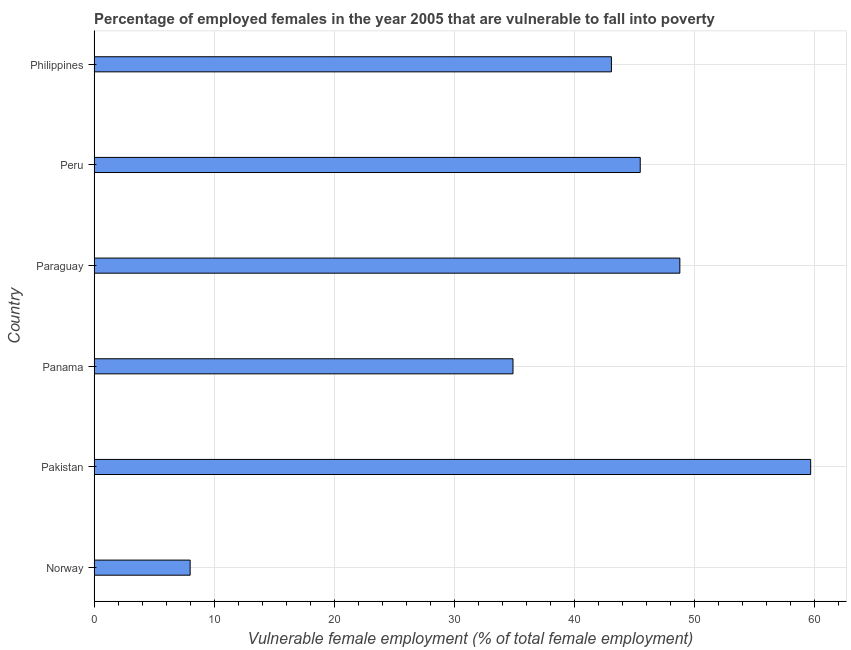Does the graph contain grids?
Provide a short and direct response. Yes. What is the title of the graph?
Offer a terse response. Percentage of employed females in the year 2005 that are vulnerable to fall into poverty. What is the label or title of the X-axis?
Provide a short and direct response. Vulnerable female employment (% of total female employment). What is the percentage of employed females who are vulnerable to fall into poverty in Peru?
Give a very brief answer. 45.5. Across all countries, what is the maximum percentage of employed females who are vulnerable to fall into poverty?
Keep it short and to the point. 59.7. Across all countries, what is the minimum percentage of employed females who are vulnerable to fall into poverty?
Keep it short and to the point. 8. In which country was the percentage of employed females who are vulnerable to fall into poverty maximum?
Offer a terse response. Pakistan. In which country was the percentage of employed females who are vulnerable to fall into poverty minimum?
Offer a terse response. Norway. What is the sum of the percentage of employed females who are vulnerable to fall into poverty?
Your answer should be very brief. 240. What is the difference between the percentage of employed females who are vulnerable to fall into poverty in Peru and Philippines?
Make the answer very short. 2.4. What is the average percentage of employed females who are vulnerable to fall into poverty per country?
Keep it short and to the point. 40. What is the median percentage of employed females who are vulnerable to fall into poverty?
Offer a terse response. 44.3. In how many countries, is the percentage of employed females who are vulnerable to fall into poverty greater than 4 %?
Your response must be concise. 6. What is the ratio of the percentage of employed females who are vulnerable to fall into poverty in Norway to that in Pakistan?
Make the answer very short. 0.13. Is the difference between the percentage of employed females who are vulnerable to fall into poverty in Peru and Philippines greater than the difference between any two countries?
Offer a very short reply. No. What is the difference between the highest and the lowest percentage of employed females who are vulnerable to fall into poverty?
Provide a succinct answer. 51.7. In how many countries, is the percentage of employed females who are vulnerable to fall into poverty greater than the average percentage of employed females who are vulnerable to fall into poverty taken over all countries?
Provide a short and direct response. 4. How many bars are there?
Ensure brevity in your answer.  6. Are all the bars in the graph horizontal?
Your answer should be very brief. Yes. How many countries are there in the graph?
Ensure brevity in your answer.  6. Are the values on the major ticks of X-axis written in scientific E-notation?
Ensure brevity in your answer.  No. What is the Vulnerable female employment (% of total female employment) of Norway?
Your response must be concise. 8. What is the Vulnerable female employment (% of total female employment) of Pakistan?
Keep it short and to the point. 59.7. What is the Vulnerable female employment (% of total female employment) in Panama?
Give a very brief answer. 34.9. What is the Vulnerable female employment (% of total female employment) in Paraguay?
Offer a terse response. 48.8. What is the Vulnerable female employment (% of total female employment) of Peru?
Provide a short and direct response. 45.5. What is the Vulnerable female employment (% of total female employment) of Philippines?
Offer a very short reply. 43.1. What is the difference between the Vulnerable female employment (% of total female employment) in Norway and Pakistan?
Your answer should be very brief. -51.7. What is the difference between the Vulnerable female employment (% of total female employment) in Norway and Panama?
Ensure brevity in your answer.  -26.9. What is the difference between the Vulnerable female employment (% of total female employment) in Norway and Paraguay?
Offer a terse response. -40.8. What is the difference between the Vulnerable female employment (% of total female employment) in Norway and Peru?
Provide a succinct answer. -37.5. What is the difference between the Vulnerable female employment (% of total female employment) in Norway and Philippines?
Provide a short and direct response. -35.1. What is the difference between the Vulnerable female employment (% of total female employment) in Pakistan and Panama?
Your answer should be very brief. 24.8. What is the difference between the Vulnerable female employment (% of total female employment) in Pakistan and Paraguay?
Ensure brevity in your answer.  10.9. What is the difference between the Vulnerable female employment (% of total female employment) in Pakistan and Philippines?
Offer a terse response. 16.6. What is the difference between the Vulnerable female employment (% of total female employment) in Panama and Paraguay?
Ensure brevity in your answer.  -13.9. What is the difference between the Vulnerable female employment (% of total female employment) in Panama and Peru?
Give a very brief answer. -10.6. What is the difference between the Vulnerable female employment (% of total female employment) in Panama and Philippines?
Provide a succinct answer. -8.2. What is the ratio of the Vulnerable female employment (% of total female employment) in Norway to that in Pakistan?
Give a very brief answer. 0.13. What is the ratio of the Vulnerable female employment (% of total female employment) in Norway to that in Panama?
Provide a short and direct response. 0.23. What is the ratio of the Vulnerable female employment (% of total female employment) in Norway to that in Paraguay?
Make the answer very short. 0.16. What is the ratio of the Vulnerable female employment (% of total female employment) in Norway to that in Peru?
Your answer should be compact. 0.18. What is the ratio of the Vulnerable female employment (% of total female employment) in Norway to that in Philippines?
Ensure brevity in your answer.  0.19. What is the ratio of the Vulnerable female employment (% of total female employment) in Pakistan to that in Panama?
Give a very brief answer. 1.71. What is the ratio of the Vulnerable female employment (% of total female employment) in Pakistan to that in Paraguay?
Your answer should be compact. 1.22. What is the ratio of the Vulnerable female employment (% of total female employment) in Pakistan to that in Peru?
Your answer should be very brief. 1.31. What is the ratio of the Vulnerable female employment (% of total female employment) in Pakistan to that in Philippines?
Offer a terse response. 1.39. What is the ratio of the Vulnerable female employment (% of total female employment) in Panama to that in Paraguay?
Ensure brevity in your answer.  0.71. What is the ratio of the Vulnerable female employment (% of total female employment) in Panama to that in Peru?
Make the answer very short. 0.77. What is the ratio of the Vulnerable female employment (% of total female employment) in Panama to that in Philippines?
Your answer should be very brief. 0.81. What is the ratio of the Vulnerable female employment (% of total female employment) in Paraguay to that in Peru?
Your response must be concise. 1.07. What is the ratio of the Vulnerable female employment (% of total female employment) in Paraguay to that in Philippines?
Keep it short and to the point. 1.13. What is the ratio of the Vulnerable female employment (% of total female employment) in Peru to that in Philippines?
Offer a very short reply. 1.06. 